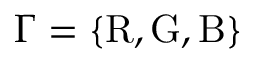Convert formula to latex. <formula><loc_0><loc_0><loc_500><loc_500>\Gamma = \{ R , G , B \}</formula> 